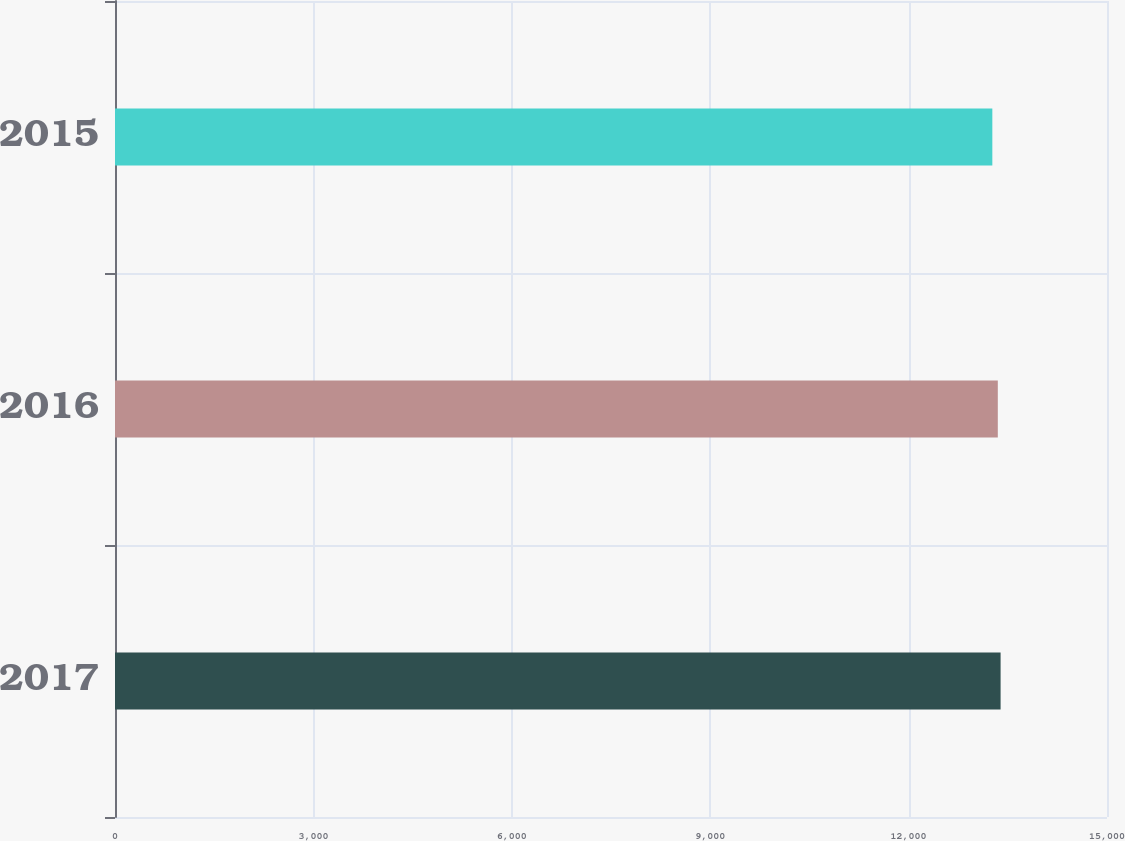Convert chart to OTSL. <chart><loc_0><loc_0><loc_500><loc_500><bar_chart><fcel>2017<fcel>2016<fcel>2015<nl><fcel>13391<fcel>13349<fcel>13266<nl></chart> 